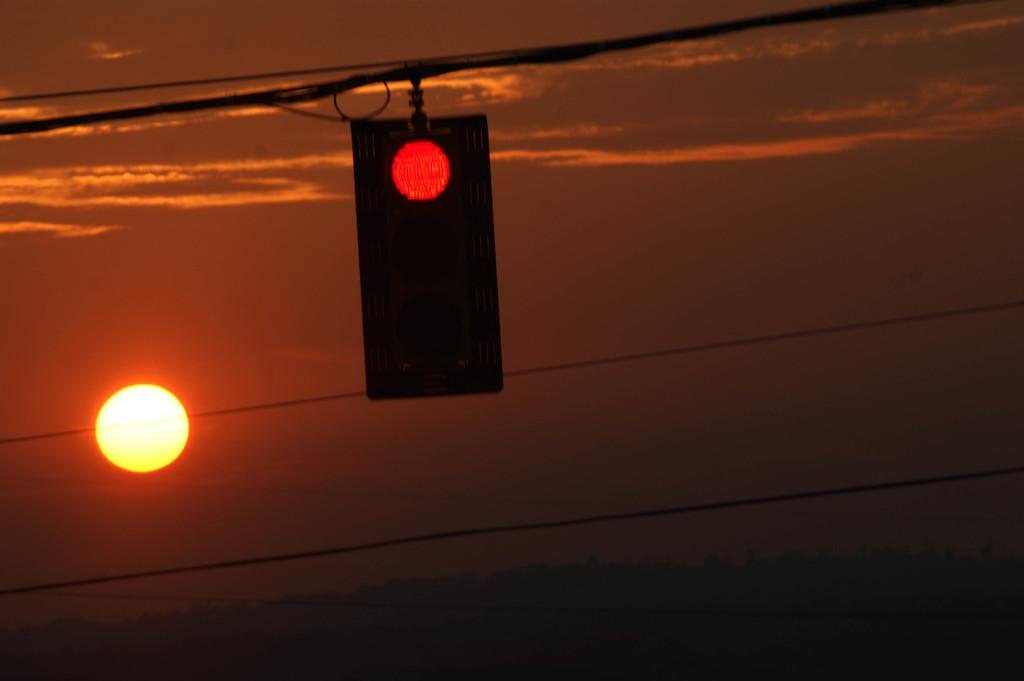What is located in the middle of the image? Wires are located in the middle of the image. What is attached to the wires? A traffic signal is attached to the wires. What can be seen in the sky? Clouds and the sun can be seen in the sky. How many celestial bodies are visible in the sky? One celestial body, the sun, is visible in the sky. What is the weather like in the image? The presence of clouds and the visible sun suggest it is partly cloudy. What type of hose can be seen connected to the traffic signal in the image? There is no hose connected to the traffic signal in the image. How many bricks are visible in the image? There are no bricks present in the image. 